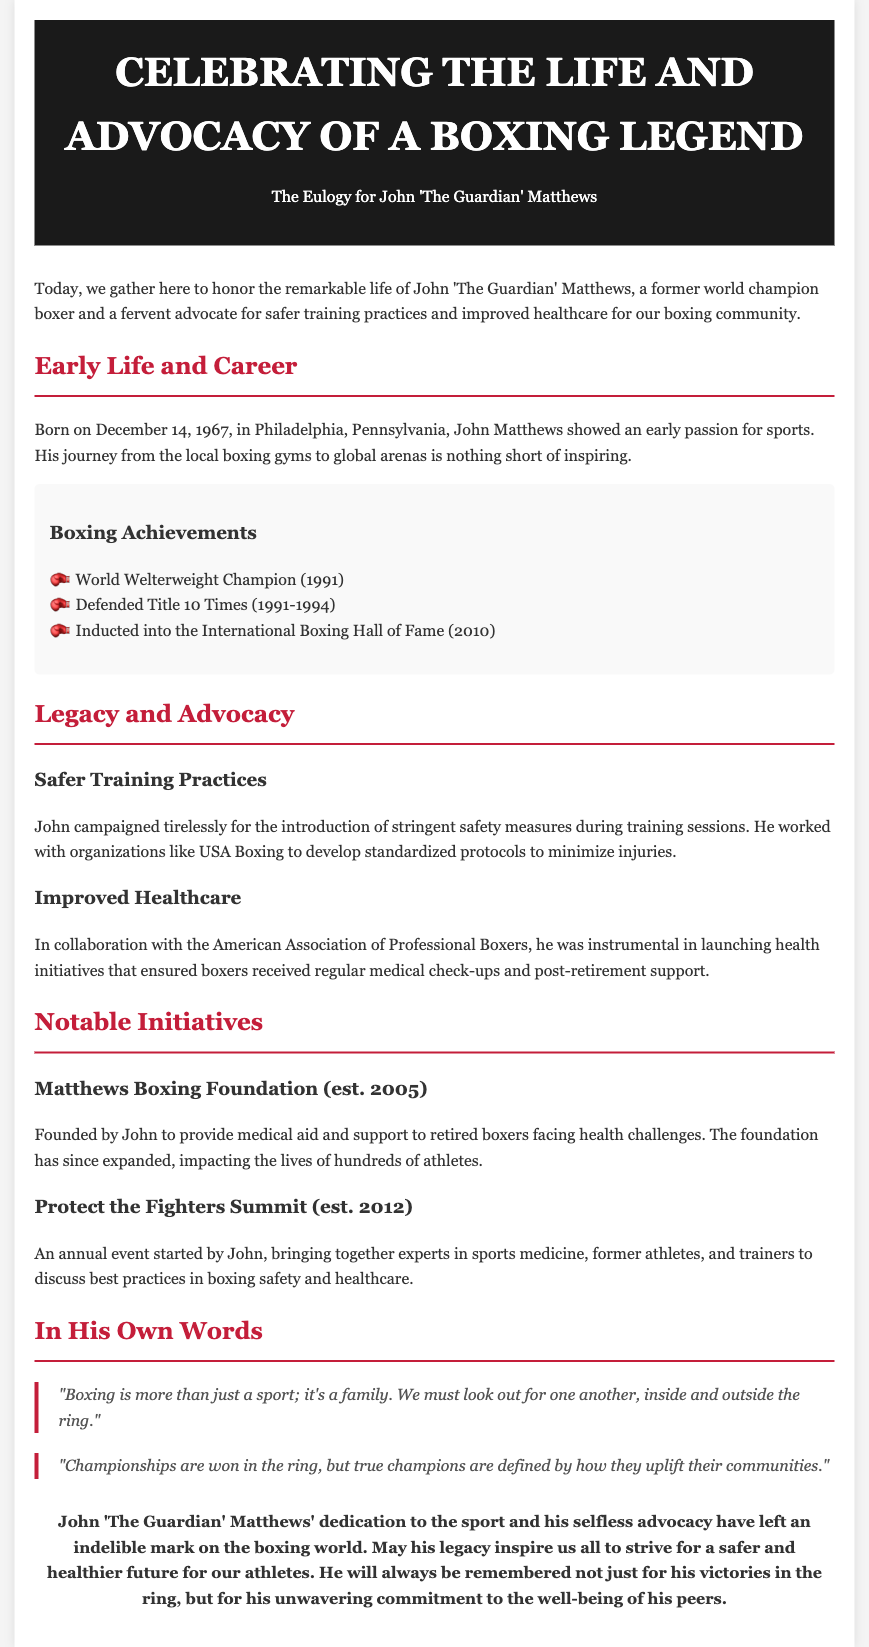What is the birth date of John Matthews? The document states that John Matthews was born on December 14, 1967.
Answer: December 14, 1967 What was John Matthews' boxing championship title? John Matthews is referred to as the World Welterweight Champion in the achievements section of the document.
Answer: World Welterweight Champion How many times did John defend his title? The document mentions that John defended his title 10 times from 1991 to 1994.
Answer: 10 times What health initiative did John help launch? The document states he was instrumental in launching health initiatives in collaboration with the American Association of Professional Boxers.
Answer: Health initiatives What year was the Matthews Boxing Foundation established? The document indicates that the Matthews Boxing Foundation was established in 2005.
Answer: 2005 What is one of John Matthews' notable quotes? The document provides a quote by John emphasizing community within boxing.
Answer: "Boxing is more than just a sport; it's a family." What was the purpose of the Protect the Fighters Summit? The document describes it as an event to discuss best practices in boxing safety and healthcare.
Answer: Discuss boxing safety and healthcare What is a key focus of John Matthews' advocacy? The document emphasizes his advocacy for safer training practices and improved healthcare for boxers.
Answer: Safer training practices and improved healthcare 